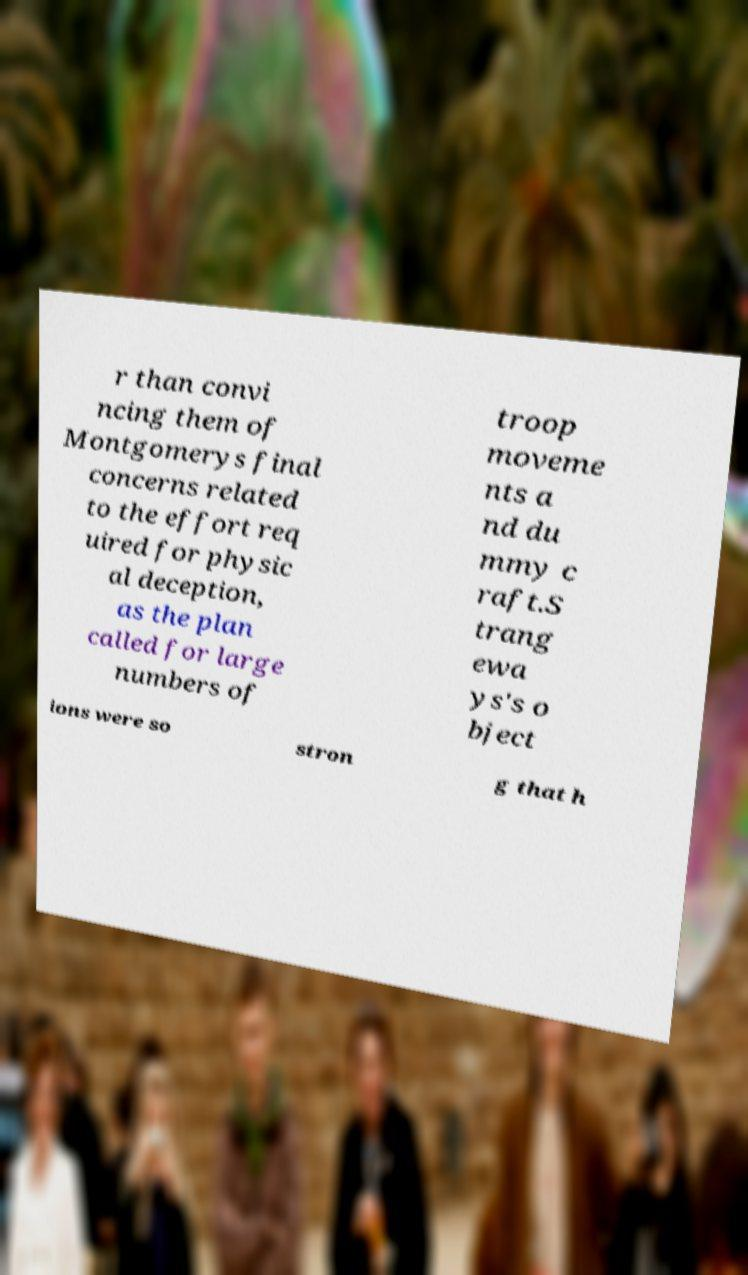What messages or text are displayed in this image? I need them in a readable, typed format. r than convi ncing them of Montgomerys final concerns related to the effort req uired for physic al deception, as the plan called for large numbers of troop moveme nts a nd du mmy c raft.S trang ewa ys's o bject ions were so stron g that h 